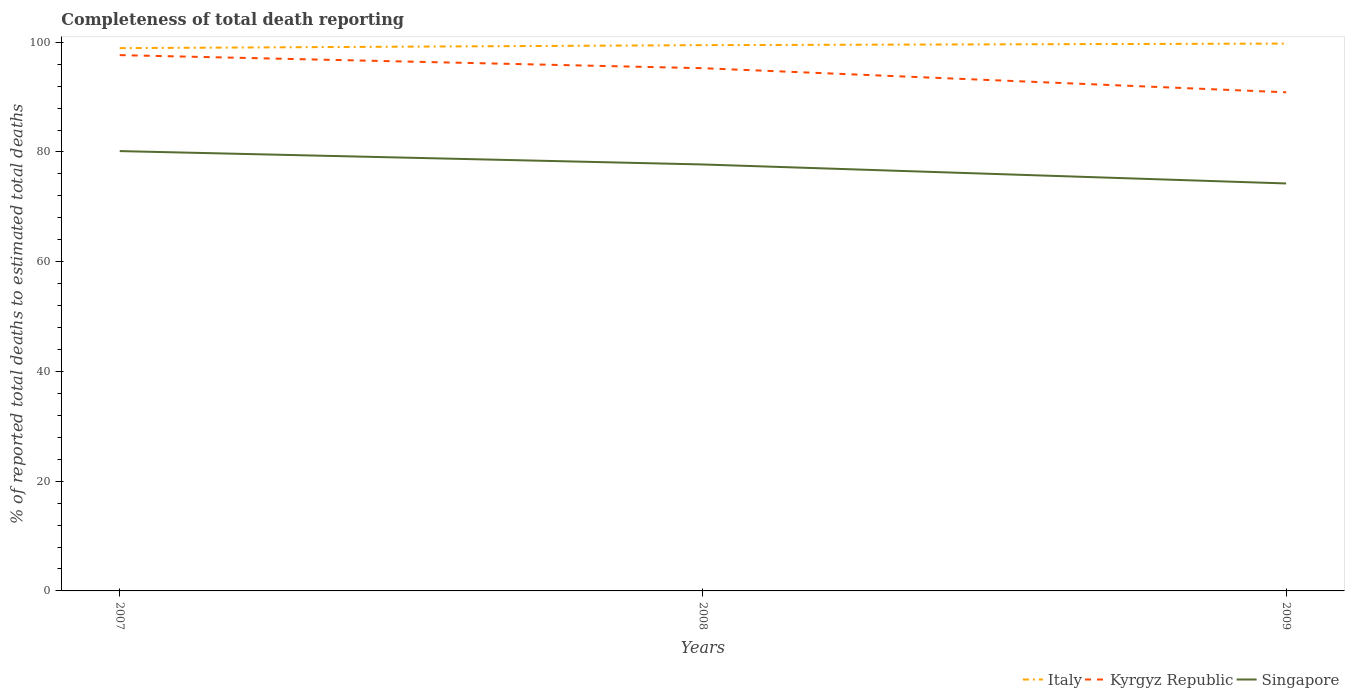Does the line corresponding to Kyrgyz Republic intersect with the line corresponding to Italy?
Your response must be concise. No. Is the number of lines equal to the number of legend labels?
Your answer should be very brief. Yes. Across all years, what is the maximum percentage of total deaths reported in Italy?
Give a very brief answer. 98.92. What is the total percentage of total deaths reported in Singapore in the graph?
Offer a terse response. 5.9. What is the difference between the highest and the second highest percentage of total deaths reported in Singapore?
Offer a very short reply. 5.9. What is the difference between the highest and the lowest percentage of total deaths reported in Kyrgyz Republic?
Provide a succinct answer. 2. Is the percentage of total deaths reported in Kyrgyz Republic strictly greater than the percentage of total deaths reported in Singapore over the years?
Your response must be concise. No. How many lines are there?
Provide a short and direct response. 3. How many years are there in the graph?
Provide a succinct answer. 3. What is the difference between two consecutive major ticks on the Y-axis?
Your answer should be very brief. 20. Does the graph contain grids?
Your answer should be compact. No. Where does the legend appear in the graph?
Keep it short and to the point. Bottom right. How many legend labels are there?
Provide a short and direct response. 3. How are the legend labels stacked?
Your answer should be compact. Horizontal. What is the title of the graph?
Provide a succinct answer. Completeness of total death reporting. Does "Botswana" appear as one of the legend labels in the graph?
Provide a short and direct response. No. What is the label or title of the Y-axis?
Your answer should be compact. % of reported total deaths to estimated total deaths. What is the % of reported total deaths to estimated total deaths of Italy in 2007?
Provide a succinct answer. 98.92. What is the % of reported total deaths to estimated total deaths in Kyrgyz Republic in 2007?
Keep it short and to the point. 97.65. What is the % of reported total deaths to estimated total deaths of Singapore in 2007?
Provide a short and direct response. 80.16. What is the % of reported total deaths to estimated total deaths of Italy in 2008?
Keep it short and to the point. 99.47. What is the % of reported total deaths to estimated total deaths in Kyrgyz Republic in 2008?
Keep it short and to the point. 95.26. What is the % of reported total deaths to estimated total deaths of Singapore in 2008?
Offer a terse response. 77.72. What is the % of reported total deaths to estimated total deaths in Italy in 2009?
Provide a succinct answer. 99.75. What is the % of reported total deaths to estimated total deaths of Kyrgyz Republic in 2009?
Make the answer very short. 90.87. What is the % of reported total deaths to estimated total deaths of Singapore in 2009?
Make the answer very short. 74.26. Across all years, what is the maximum % of reported total deaths to estimated total deaths of Italy?
Offer a terse response. 99.75. Across all years, what is the maximum % of reported total deaths to estimated total deaths in Kyrgyz Republic?
Offer a very short reply. 97.65. Across all years, what is the maximum % of reported total deaths to estimated total deaths of Singapore?
Your answer should be very brief. 80.16. Across all years, what is the minimum % of reported total deaths to estimated total deaths in Italy?
Offer a terse response. 98.92. Across all years, what is the minimum % of reported total deaths to estimated total deaths in Kyrgyz Republic?
Ensure brevity in your answer.  90.87. Across all years, what is the minimum % of reported total deaths to estimated total deaths in Singapore?
Offer a very short reply. 74.26. What is the total % of reported total deaths to estimated total deaths of Italy in the graph?
Your answer should be compact. 298.14. What is the total % of reported total deaths to estimated total deaths in Kyrgyz Republic in the graph?
Give a very brief answer. 283.79. What is the total % of reported total deaths to estimated total deaths in Singapore in the graph?
Your answer should be compact. 232.14. What is the difference between the % of reported total deaths to estimated total deaths of Italy in 2007 and that in 2008?
Your answer should be compact. -0.54. What is the difference between the % of reported total deaths to estimated total deaths of Kyrgyz Republic in 2007 and that in 2008?
Ensure brevity in your answer.  2.38. What is the difference between the % of reported total deaths to estimated total deaths in Singapore in 2007 and that in 2008?
Provide a short and direct response. 2.44. What is the difference between the % of reported total deaths to estimated total deaths of Italy in 2007 and that in 2009?
Provide a succinct answer. -0.83. What is the difference between the % of reported total deaths to estimated total deaths in Kyrgyz Republic in 2007 and that in 2009?
Offer a very short reply. 6.77. What is the difference between the % of reported total deaths to estimated total deaths in Singapore in 2007 and that in 2009?
Give a very brief answer. 5.9. What is the difference between the % of reported total deaths to estimated total deaths of Italy in 2008 and that in 2009?
Provide a succinct answer. -0.29. What is the difference between the % of reported total deaths to estimated total deaths of Kyrgyz Republic in 2008 and that in 2009?
Provide a succinct answer. 4.39. What is the difference between the % of reported total deaths to estimated total deaths of Singapore in 2008 and that in 2009?
Provide a short and direct response. 3.46. What is the difference between the % of reported total deaths to estimated total deaths in Italy in 2007 and the % of reported total deaths to estimated total deaths in Kyrgyz Republic in 2008?
Give a very brief answer. 3.66. What is the difference between the % of reported total deaths to estimated total deaths in Italy in 2007 and the % of reported total deaths to estimated total deaths in Singapore in 2008?
Keep it short and to the point. 21.2. What is the difference between the % of reported total deaths to estimated total deaths in Kyrgyz Republic in 2007 and the % of reported total deaths to estimated total deaths in Singapore in 2008?
Offer a very short reply. 19.93. What is the difference between the % of reported total deaths to estimated total deaths in Italy in 2007 and the % of reported total deaths to estimated total deaths in Kyrgyz Republic in 2009?
Provide a short and direct response. 8.05. What is the difference between the % of reported total deaths to estimated total deaths of Italy in 2007 and the % of reported total deaths to estimated total deaths of Singapore in 2009?
Provide a succinct answer. 24.67. What is the difference between the % of reported total deaths to estimated total deaths in Kyrgyz Republic in 2007 and the % of reported total deaths to estimated total deaths in Singapore in 2009?
Ensure brevity in your answer.  23.39. What is the difference between the % of reported total deaths to estimated total deaths in Italy in 2008 and the % of reported total deaths to estimated total deaths in Kyrgyz Republic in 2009?
Offer a terse response. 8.59. What is the difference between the % of reported total deaths to estimated total deaths of Italy in 2008 and the % of reported total deaths to estimated total deaths of Singapore in 2009?
Your answer should be compact. 25.21. What is the difference between the % of reported total deaths to estimated total deaths of Kyrgyz Republic in 2008 and the % of reported total deaths to estimated total deaths of Singapore in 2009?
Offer a terse response. 21. What is the average % of reported total deaths to estimated total deaths in Italy per year?
Provide a short and direct response. 99.38. What is the average % of reported total deaths to estimated total deaths of Kyrgyz Republic per year?
Provide a succinct answer. 94.6. What is the average % of reported total deaths to estimated total deaths of Singapore per year?
Your response must be concise. 77.38. In the year 2007, what is the difference between the % of reported total deaths to estimated total deaths of Italy and % of reported total deaths to estimated total deaths of Kyrgyz Republic?
Your answer should be very brief. 1.28. In the year 2007, what is the difference between the % of reported total deaths to estimated total deaths of Italy and % of reported total deaths to estimated total deaths of Singapore?
Offer a terse response. 18.77. In the year 2007, what is the difference between the % of reported total deaths to estimated total deaths in Kyrgyz Republic and % of reported total deaths to estimated total deaths in Singapore?
Offer a very short reply. 17.49. In the year 2008, what is the difference between the % of reported total deaths to estimated total deaths in Italy and % of reported total deaths to estimated total deaths in Kyrgyz Republic?
Your answer should be compact. 4.2. In the year 2008, what is the difference between the % of reported total deaths to estimated total deaths of Italy and % of reported total deaths to estimated total deaths of Singapore?
Provide a succinct answer. 21.75. In the year 2008, what is the difference between the % of reported total deaths to estimated total deaths in Kyrgyz Republic and % of reported total deaths to estimated total deaths in Singapore?
Offer a very short reply. 17.54. In the year 2009, what is the difference between the % of reported total deaths to estimated total deaths of Italy and % of reported total deaths to estimated total deaths of Kyrgyz Republic?
Make the answer very short. 8.88. In the year 2009, what is the difference between the % of reported total deaths to estimated total deaths of Italy and % of reported total deaths to estimated total deaths of Singapore?
Make the answer very short. 25.49. In the year 2009, what is the difference between the % of reported total deaths to estimated total deaths in Kyrgyz Republic and % of reported total deaths to estimated total deaths in Singapore?
Offer a very short reply. 16.62. What is the ratio of the % of reported total deaths to estimated total deaths in Kyrgyz Republic in 2007 to that in 2008?
Make the answer very short. 1.02. What is the ratio of the % of reported total deaths to estimated total deaths in Singapore in 2007 to that in 2008?
Keep it short and to the point. 1.03. What is the ratio of the % of reported total deaths to estimated total deaths in Kyrgyz Republic in 2007 to that in 2009?
Give a very brief answer. 1.07. What is the ratio of the % of reported total deaths to estimated total deaths of Singapore in 2007 to that in 2009?
Keep it short and to the point. 1.08. What is the ratio of the % of reported total deaths to estimated total deaths of Kyrgyz Republic in 2008 to that in 2009?
Keep it short and to the point. 1.05. What is the ratio of the % of reported total deaths to estimated total deaths of Singapore in 2008 to that in 2009?
Keep it short and to the point. 1.05. What is the difference between the highest and the second highest % of reported total deaths to estimated total deaths in Italy?
Offer a terse response. 0.29. What is the difference between the highest and the second highest % of reported total deaths to estimated total deaths of Kyrgyz Republic?
Keep it short and to the point. 2.38. What is the difference between the highest and the second highest % of reported total deaths to estimated total deaths of Singapore?
Your response must be concise. 2.44. What is the difference between the highest and the lowest % of reported total deaths to estimated total deaths in Italy?
Make the answer very short. 0.83. What is the difference between the highest and the lowest % of reported total deaths to estimated total deaths of Kyrgyz Republic?
Provide a succinct answer. 6.77. What is the difference between the highest and the lowest % of reported total deaths to estimated total deaths in Singapore?
Ensure brevity in your answer.  5.9. 